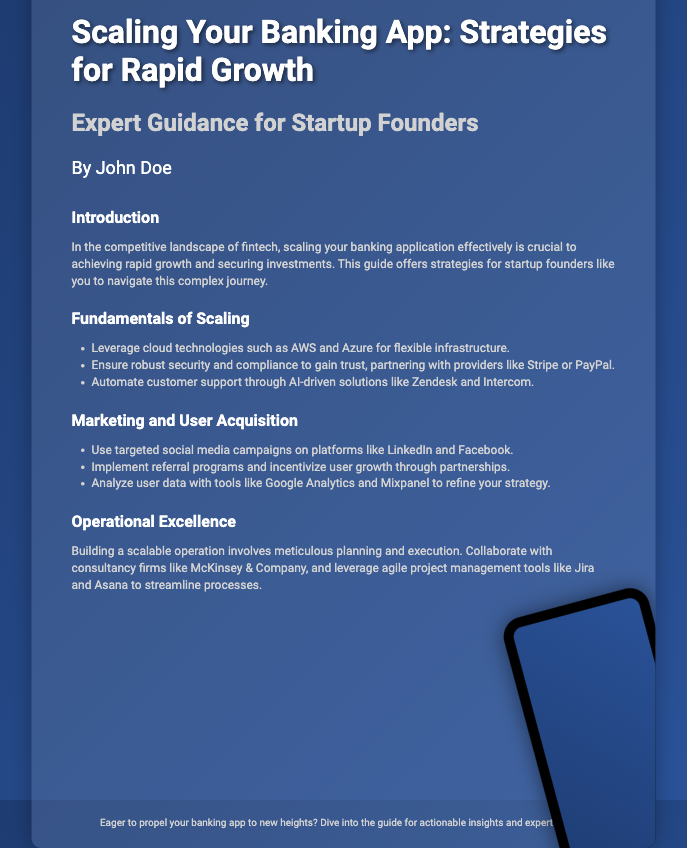What is the title of the book? The title of the book is prominently displayed at the top of the cover.
Answer: Scaling Your Banking App: Strategies for Rapid Growth Who is the author of the book? The author's name is mentioned below the title, indicating who wrote the book.
Answer: John Doe What is the main focus of the book? The introduction section outlines the purpose of the book, highlighting its focus on scaling banking applications.
Answer: Scaling your banking application effectively Which technology is suggested for flexible infrastructure? The fundamentals of scaling section lists cloud technologies that are recommended.
Answer: AWS and Azure What is a method mentioned for automating customer support? The fundamentals of scaling section includes examples of solutions for automation.
Answer: AI-driven solutions What type of campaign is recommended for user acquisition? The marketing and user acquisition section contains strategies for acquiring users.
Answer: Targeted social media campaigns What consultancy firm is suggested for operational excellence? The section on operational excellence mentions a specific consultancy for collaboration.
Answer: McKinsey & Company What project management tools are recommended? The operational excellence section lists tools to streamline processes.
Answer: Jira and Asana What is offered as a takeaway in the footer? The footer provides a call to action or a takeaway from reading the book.
Answer: Actionable insights and expert advice 